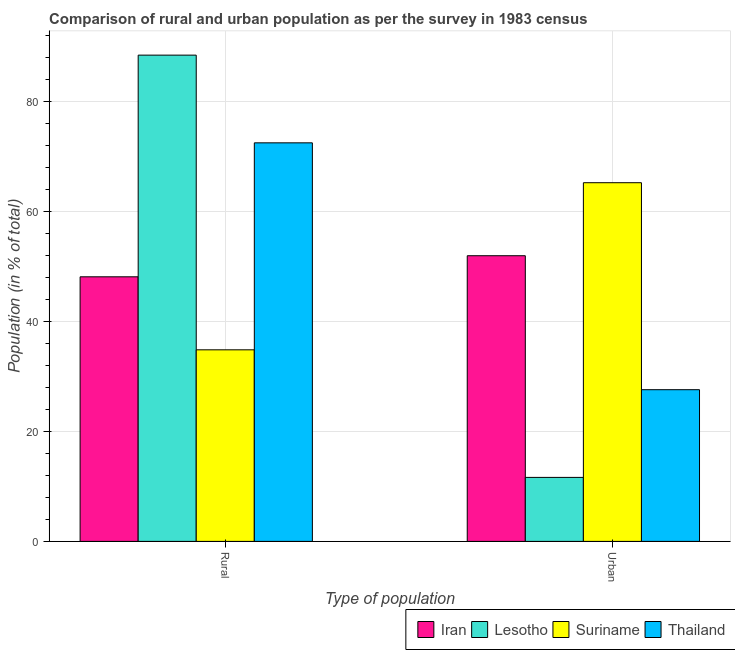How many different coloured bars are there?
Your response must be concise. 4. How many groups of bars are there?
Make the answer very short. 2. Are the number of bars on each tick of the X-axis equal?
Ensure brevity in your answer.  Yes. What is the label of the 1st group of bars from the left?
Your response must be concise. Rural. What is the rural population in Thailand?
Keep it short and to the point. 72.43. Across all countries, what is the maximum urban population?
Ensure brevity in your answer.  65.18. Across all countries, what is the minimum urban population?
Your response must be concise. 11.63. In which country was the rural population maximum?
Provide a succinct answer. Lesotho. In which country was the urban population minimum?
Ensure brevity in your answer.  Lesotho. What is the total urban population in the graph?
Your answer should be very brief. 156.3. What is the difference between the rural population in Suriname and that in Lesotho?
Offer a very short reply. -53.55. What is the difference between the urban population in Suriname and the rural population in Thailand?
Your answer should be very brief. -7.25. What is the average rural population per country?
Ensure brevity in your answer.  60.93. What is the difference between the rural population and urban population in Iran?
Provide a short and direct response. -3.83. What is the ratio of the rural population in Thailand to that in Iran?
Provide a succinct answer. 1.51. In how many countries, is the urban population greater than the average urban population taken over all countries?
Give a very brief answer. 2. What does the 4th bar from the left in Rural represents?
Provide a succinct answer. Thailand. What does the 1st bar from the right in Urban represents?
Provide a short and direct response. Thailand. What is the difference between two consecutive major ticks on the Y-axis?
Make the answer very short. 20. How are the legend labels stacked?
Your answer should be very brief. Horizontal. What is the title of the graph?
Make the answer very short. Comparison of rural and urban population as per the survey in 1983 census. Does "Andorra" appear as one of the legend labels in the graph?
Ensure brevity in your answer.  No. What is the label or title of the X-axis?
Your answer should be very brief. Type of population. What is the label or title of the Y-axis?
Offer a terse response. Population (in % of total). What is the Population (in % of total) of Iran in Rural?
Your answer should be very brief. 48.08. What is the Population (in % of total) of Lesotho in Rural?
Provide a succinct answer. 88.37. What is the Population (in % of total) of Suriname in Rural?
Your answer should be compact. 34.82. What is the Population (in % of total) of Thailand in Rural?
Give a very brief answer. 72.43. What is the Population (in % of total) of Iran in Urban?
Offer a very short reply. 51.92. What is the Population (in % of total) in Lesotho in Urban?
Your response must be concise. 11.63. What is the Population (in % of total) in Suriname in Urban?
Your answer should be compact. 65.18. What is the Population (in % of total) of Thailand in Urban?
Give a very brief answer. 27.57. Across all Type of population, what is the maximum Population (in % of total) in Iran?
Your answer should be very brief. 51.92. Across all Type of population, what is the maximum Population (in % of total) in Lesotho?
Provide a succinct answer. 88.37. Across all Type of population, what is the maximum Population (in % of total) of Suriname?
Your answer should be very brief. 65.18. Across all Type of population, what is the maximum Population (in % of total) in Thailand?
Give a very brief answer. 72.43. Across all Type of population, what is the minimum Population (in % of total) of Iran?
Give a very brief answer. 48.08. Across all Type of population, what is the minimum Population (in % of total) of Lesotho?
Offer a terse response. 11.63. Across all Type of population, what is the minimum Population (in % of total) of Suriname?
Provide a succinct answer. 34.82. Across all Type of population, what is the minimum Population (in % of total) in Thailand?
Offer a terse response. 27.57. What is the total Population (in % of total) of Suriname in the graph?
Offer a very short reply. 100. What is the total Population (in % of total) of Thailand in the graph?
Your answer should be compact. 100. What is the difference between the Population (in % of total) of Iran in Rural and that in Urban?
Offer a terse response. -3.83. What is the difference between the Population (in % of total) of Lesotho in Rural and that in Urban?
Make the answer very short. 76.74. What is the difference between the Population (in % of total) in Suriname in Rural and that in Urban?
Offer a very short reply. -30.37. What is the difference between the Population (in % of total) in Thailand in Rural and that in Urban?
Offer a very short reply. 44.86. What is the difference between the Population (in % of total) in Iran in Rural and the Population (in % of total) in Lesotho in Urban?
Ensure brevity in your answer.  36.45. What is the difference between the Population (in % of total) in Iran in Rural and the Population (in % of total) in Suriname in Urban?
Offer a terse response. -17.1. What is the difference between the Population (in % of total) in Iran in Rural and the Population (in % of total) in Thailand in Urban?
Offer a very short reply. 20.52. What is the difference between the Population (in % of total) of Lesotho in Rural and the Population (in % of total) of Suriname in Urban?
Provide a succinct answer. 23.19. What is the difference between the Population (in % of total) of Lesotho in Rural and the Population (in % of total) of Thailand in Urban?
Your response must be concise. 60.8. What is the difference between the Population (in % of total) in Suriname in Rural and the Population (in % of total) in Thailand in Urban?
Provide a short and direct response. 7.25. What is the average Population (in % of total) in Iran per Type of population?
Your answer should be compact. 50. What is the average Population (in % of total) of Lesotho per Type of population?
Provide a succinct answer. 50. What is the average Population (in % of total) of Suriname per Type of population?
Provide a short and direct response. 50. What is the difference between the Population (in % of total) of Iran and Population (in % of total) of Lesotho in Rural?
Offer a very short reply. -40.29. What is the difference between the Population (in % of total) of Iran and Population (in % of total) of Suriname in Rural?
Your response must be concise. 13.27. What is the difference between the Population (in % of total) of Iran and Population (in % of total) of Thailand in Rural?
Your answer should be very brief. -24.35. What is the difference between the Population (in % of total) in Lesotho and Population (in % of total) in Suriname in Rural?
Ensure brevity in your answer.  53.55. What is the difference between the Population (in % of total) in Lesotho and Population (in % of total) in Thailand in Rural?
Offer a terse response. 15.94. What is the difference between the Population (in % of total) in Suriname and Population (in % of total) in Thailand in Rural?
Give a very brief answer. -37.62. What is the difference between the Population (in % of total) in Iran and Population (in % of total) in Lesotho in Urban?
Ensure brevity in your answer.  40.29. What is the difference between the Population (in % of total) of Iran and Population (in % of total) of Suriname in Urban?
Your response must be concise. -13.27. What is the difference between the Population (in % of total) of Iran and Population (in % of total) of Thailand in Urban?
Ensure brevity in your answer.  24.35. What is the difference between the Population (in % of total) in Lesotho and Population (in % of total) in Suriname in Urban?
Your answer should be compact. -53.55. What is the difference between the Population (in % of total) of Lesotho and Population (in % of total) of Thailand in Urban?
Provide a short and direct response. -15.94. What is the difference between the Population (in % of total) in Suriname and Population (in % of total) in Thailand in Urban?
Ensure brevity in your answer.  37.62. What is the ratio of the Population (in % of total) in Iran in Rural to that in Urban?
Your response must be concise. 0.93. What is the ratio of the Population (in % of total) in Lesotho in Rural to that in Urban?
Offer a terse response. 7.6. What is the ratio of the Population (in % of total) in Suriname in Rural to that in Urban?
Your answer should be very brief. 0.53. What is the ratio of the Population (in % of total) of Thailand in Rural to that in Urban?
Provide a short and direct response. 2.63. What is the difference between the highest and the second highest Population (in % of total) in Iran?
Your response must be concise. 3.83. What is the difference between the highest and the second highest Population (in % of total) in Lesotho?
Keep it short and to the point. 76.74. What is the difference between the highest and the second highest Population (in % of total) of Suriname?
Ensure brevity in your answer.  30.37. What is the difference between the highest and the second highest Population (in % of total) in Thailand?
Make the answer very short. 44.86. What is the difference between the highest and the lowest Population (in % of total) in Iran?
Keep it short and to the point. 3.83. What is the difference between the highest and the lowest Population (in % of total) in Lesotho?
Keep it short and to the point. 76.74. What is the difference between the highest and the lowest Population (in % of total) in Suriname?
Give a very brief answer. 30.37. What is the difference between the highest and the lowest Population (in % of total) of Thailand?
Provide a short and direct response. 44.86. 